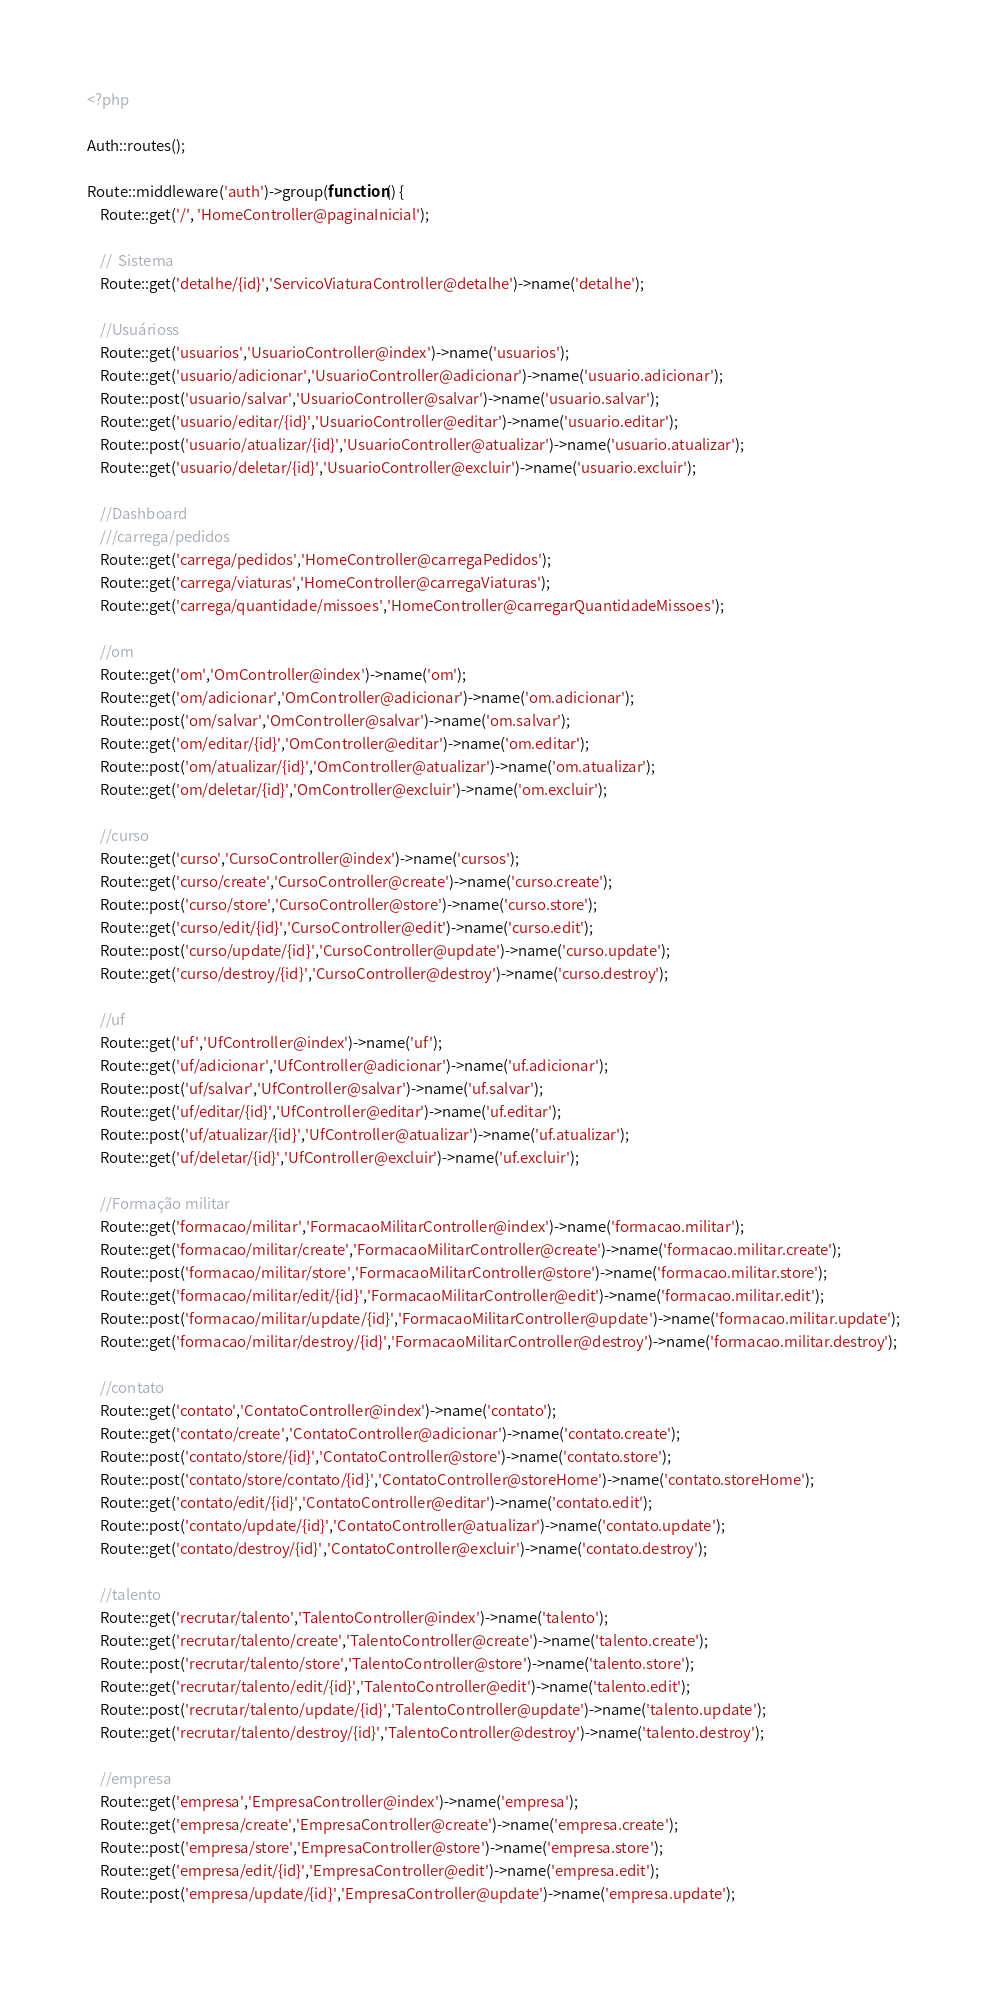Convert code to text. <code><loc_0><loc_0><loc_500><loc_500><_PHP_><?php

Auth::routes();

Route::middleware('auth')->group(function() {
    Route::get('/', 'HomeController@paginaInicial');

    //	Sistema
    Route::get('detalhe/{id}','ServicoViaturaController@detalhe')->name('detalhe');

    //Usuárioss
    Route::get('usuarios','UsuarioController@index')->name('usuarios');
    Route::get('usuario/adicionar','UsuarioController@adicionar')->name('usuario.adicionar');
    Route::post('usuario/salvar','UsuarioController@salvar')->name('usuario.salvar');
    Route::get('usuario/editar/{id}','UsuarioController@editar')->name('usuario.editar');
    Route::post('usuario/atualizar/{id}','UsuarioController@atualizar')->name('usuario.atualizar');
    Route::get('usuario/deletar/{id}','UsuarioController@excluir')->name('usuario.excluir');

    //Dashboard
    ///carrega/pedidos
    Route::get('carrega/pedidos','HomeController@carregaPedidos');
    Route::get('carrega/viaturas','HomeController@carregaViaturas');
    Route::get('carrega/quantidade/missoes','HomeController@carregarQuantidadeMissoes');

    //om
    Route::get('om','OmController@index')->name('om');
    Route::get('om/adicionar','OmController@adicionar')->name('om.adicionar');
    Route::post('om/salvar','OmController@salvar')->name('om.salvar');
    Route::get('om/editar/{id}','OmController@editar')->name('om.editar');
    Route::post('om/atualizar/{id}','OmController@atualizar')->name('om.atualizar');
    Route::get('om/deletar/{id}','OmController@excluir')->name('om.excluir');

    //curso
    Route::get('curso','CursoController@index')->name('cursos');
    Route::get('curso/create','CursoController@create')->name('curso.create');
    Route::post('curso/store','CursoController@store')->name('curso.store');
    Route::get('curso/edit/{id}','CursoController@edit')->name('curso.edit');
    Route::post('curso/update/{id}','CursoController@update')->name('curso.update');
    Route::get('curso/destroy/{id}','CursoController@destroy')->name('curso.destroy');

    //uf
    Route::get('uf','UfController@index')->name('uf');
    Route::get('uf/adicionar','UfController@adicionar')->name('uf.adicionar');
    Route::post('uf/salvar','UfController@salvar')->name('uf.salvar');
    Route::get('uf/editar/{id}','UfController@editar')->name('uf.editar');
    Route::post('uf/atualizar/{id}','UfController@atualizar')->name('uf.atualizar');
    Route::get('uf/deletar/{id}','UfController@excluir')->name('uf.excluir');

    //Formação militar
    Route::get('formacao/militar','FormacaoMilitarController@index')->name('formacao.militar');
    Route::get('formacao/militar/create','FormacaoMilitarController@create')->name('formacao.militar.create');
    Route::post('formacao/militar/store','FormacaoMilitarController@store')->name('formacao.militar.store');
    Route::get('formacao/militar/edit/{id}','FormacaoMilitarController@edit')->name('formacao.militar.edit');
    Route::post('formacao/militar/update/{id}','FormacaoMilitarController@update')->name('formacao.militar.update');
    Route::get('formacao/militar/destroy/{id}','FormacaoMilitarController@destroy')->name('formacao.militar.destroy');

    //contato
    Route::get('contato','ContatoController@index')->name('contato');
    Route::get('contato/create','ContatoController@adicionar')->name('contato.create');
    Route::post('contato/store/{id}','ContatoController@store')->name('contato.store');
    Route::post('contato/store/contato/{id}','ContatoController@storeHome')->name('contato.storeHome');
    Route::get('contato/edit/{id}','ContatoController@editar')->name('contato.edit');
    Route::post('contato/update/{id}','ContatoController@atualizar')->name('contato.update');
    Route::get('contato/destroy/{id}','ContatoController@excluir')->name('contato.destroy');

    //talento
    Route::get('recrutar/talento','TalentoController@index')->name('talento');
    Route::get('recrutar/talento/create','TalentoController@create')->name('talento.create');
    Route::post('recrutar/talento/store','TalentoController@store')->name('talento.store');
    Route::get('recrutar/talento/edit/{id}','TalentoController@edit')->name('talento.edit');
    Route::post('recrutar/talento/update/{id}','TalentoController@update')->name('talento.update');
    Route::get('recrutar/talento/destroy/{id}','TalentoController@destroy')->name('talento.destroy');

    //empresa
    Route::get('empresa','EmpresaController@index')->name('empresa');
    Route::get('empresa/create','EmpresaController@create')->name('empresa.create');
    Route::post('empresa/store','EmpresaController@store')->name('empresa.store');
    Route::get('empresa/edit/{id}','EmpresaController@edit')->name('empresa.edit');
    Route::post('empresa/update/{id}','EmpresaController@update')->name('empresa.update');</code> 